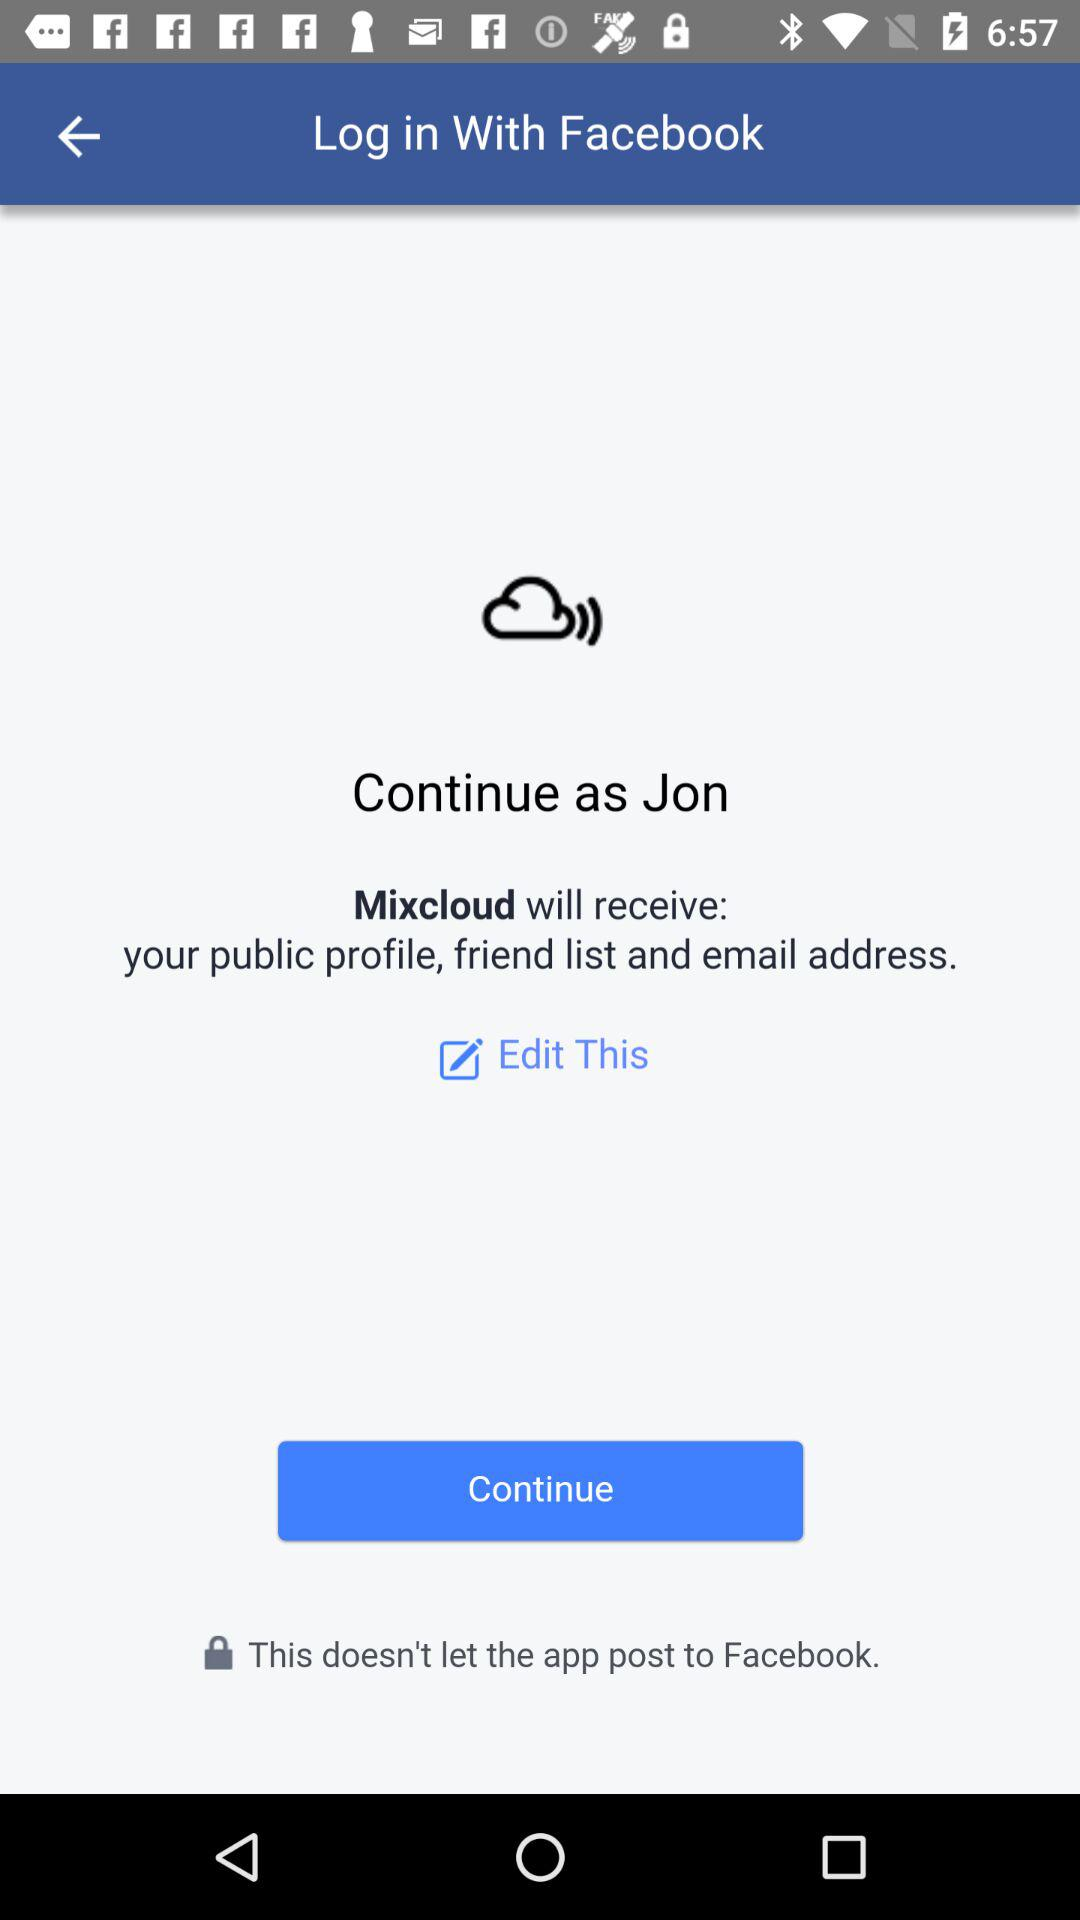Who will receive the public profile, friend list and email address? The application that will receive the public profile, friend list and email address is "Mixcloud". 